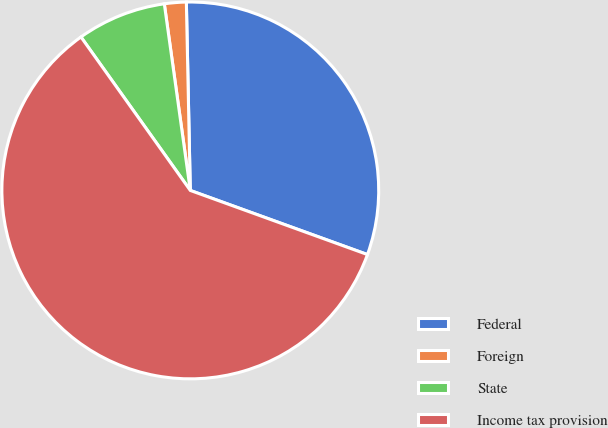Convert chart. <chart><loc_0><loc_0><loc_500><loc_500><pie_chart><fcel>Federal<fcel>Foreign<fcel>State<fcel>Income tax provision<nl><fcel>30.86%<fcel>1.87%<fcel>7.65%<fcel>59.62%<nl></chart> 